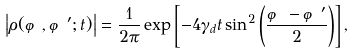Convert formula to latex. <formula><loc_0><loc_0><loc_500><loc_500>\left | \rho ( \varphi , \varphi ^ { \prime } ; t ) \right | = \frac { 1 } { 2 \pi } \exp \left [ - 4 \gamma _ { d } t \sin ^ { 2 } \left ( \frac { \varphi - \varphi ^ { \prime } } { 2 } \right ) \right ] ,</formula> 